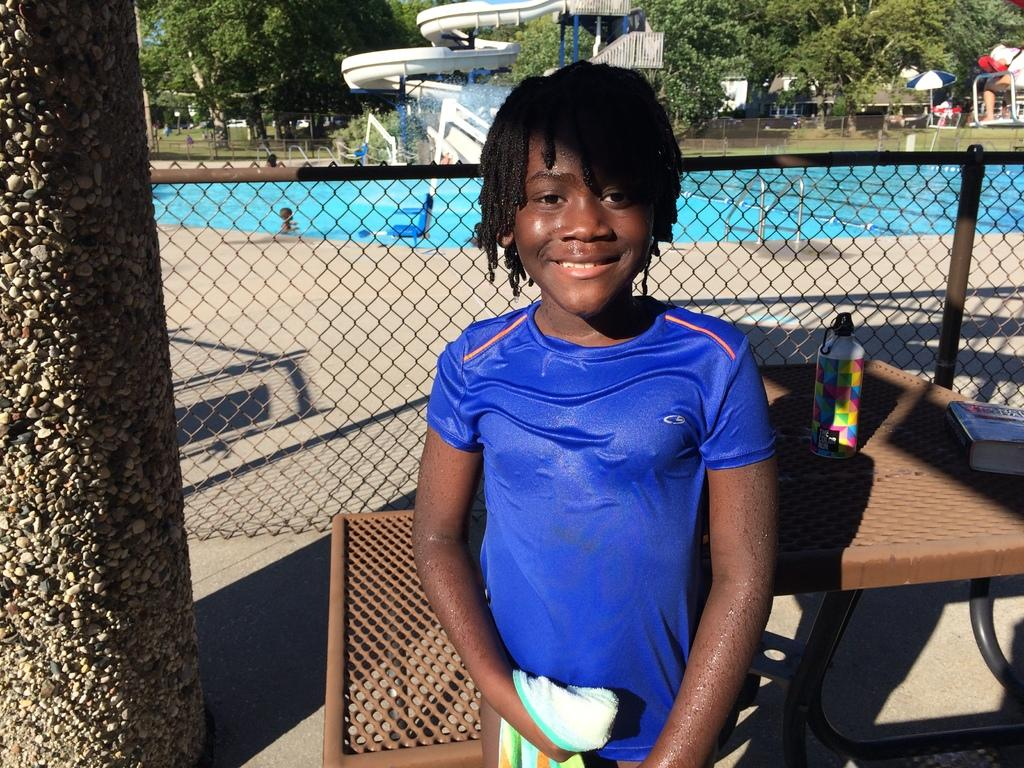What is the gender of the person in the image? The person in the image is a lady. What color is the lady person's T-shirt? The lady person is wearing a blue T-shirt. What can be seen in the background of the image? There is fencing, trees, a water slide adventure, and a pool in the background of the image. What type of board is the lady person using to play a game in the image? There is no board present in the image, and the lady person is not playing a game. 